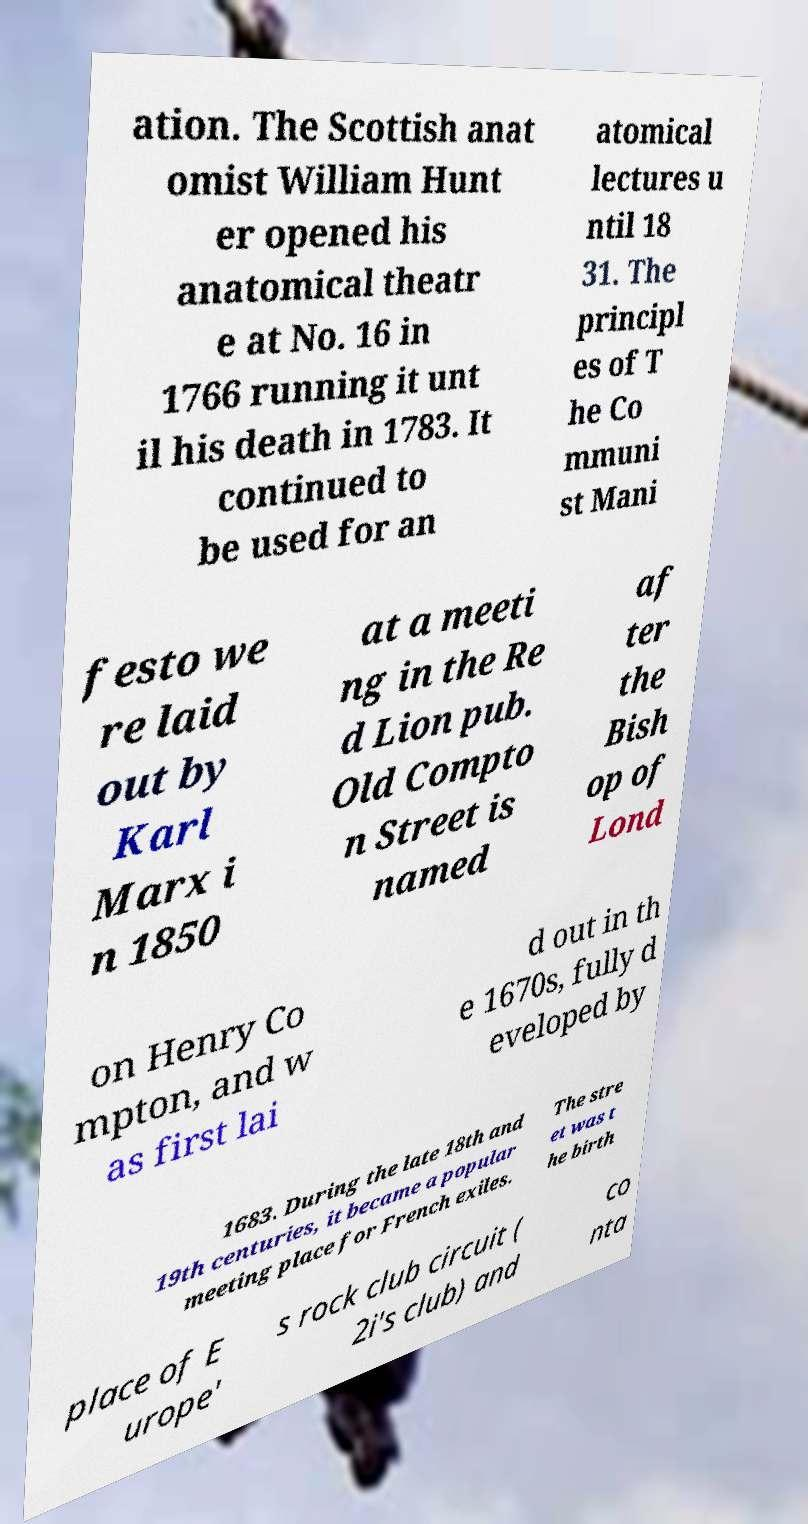What messages or text are displayed in this image? I need them in a readable, typed format. ation. The Scottish anat omist William Hunt er opened his anatomical theatr e at No. 16 in 1766 running it unt il his death in 1783. It continued to be used for an atomical lectures u ntil 18 31. The principl es of T he Co mmuni st Mani festo we re laid out by Karl Marx i n 1850 at a meeti ng in the Re d Lion pub. Old Compto n Street is named af ter the Bish op of Lond on Henry Co mpton, and w as first lai d out in th e 1670s, fully d eveloped by 1683. During the late 18th and 19th centuries, it became a popular meeting place for French exiles. The stre et was t he birth place of E urope' s rock club circuit ( 2i's club) and co nta 